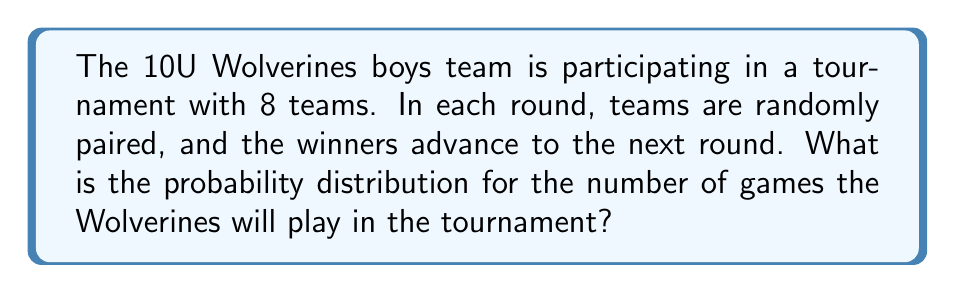What is the answer to this math problem? Let's approach this step-by-step:

1) In a tournament with 8 teams, there are 3 rounds: quarter-finals, semi-finals, and finals.

2) The Wolverines can play 1, 2, or 3 games depending on when they are eliminated or if they win the tournament.

3) To calculate the probability for each outcome:

   a) Probability of playing 1 game (losing in quarter-finals):
      $P(1 \text{ game}) = \frac{1}{2}$

   b) Probability of playing 2 games (winning quarter-finals, losing semi-finals):
      $P(2 \text{ games}) = \frac{1}{2} \cdot \frac{1}{2} = \frac{1}{4}$

   c) Probability of playing 3 games (reaching the finals):
      $P(3 \text{ games}) = \frac{1}{2} \cdot \frac{1}{2} \cdot 1 = \frac{1}{4}$

4) We can represent this as a probability distribution:

   $$
   \begin{array}{|c|c|}
   \hline
   \text{Number of games (X)} & \text{Probability P(X)} \\
   \hline
   1 & \frac{1}{2} \\
   2 & \frac{1}{4} \\
   3 & \frac{1}{4} \\
   \hline
   \end{array}
   $$

5) We can verify that these probabilities sum to 1:

   $\frac{1}{2} + \frac{1}{4} + \frac{1}{4} = 1$

This gives us the complete probability distribution for the number of games the Wolverines will play in the tournament.
Answer: $P(X=1) = \frac{1}{2}, P(X=2) = \frac{1}{4}, P(X=3) = \frac{1}{4}$ 